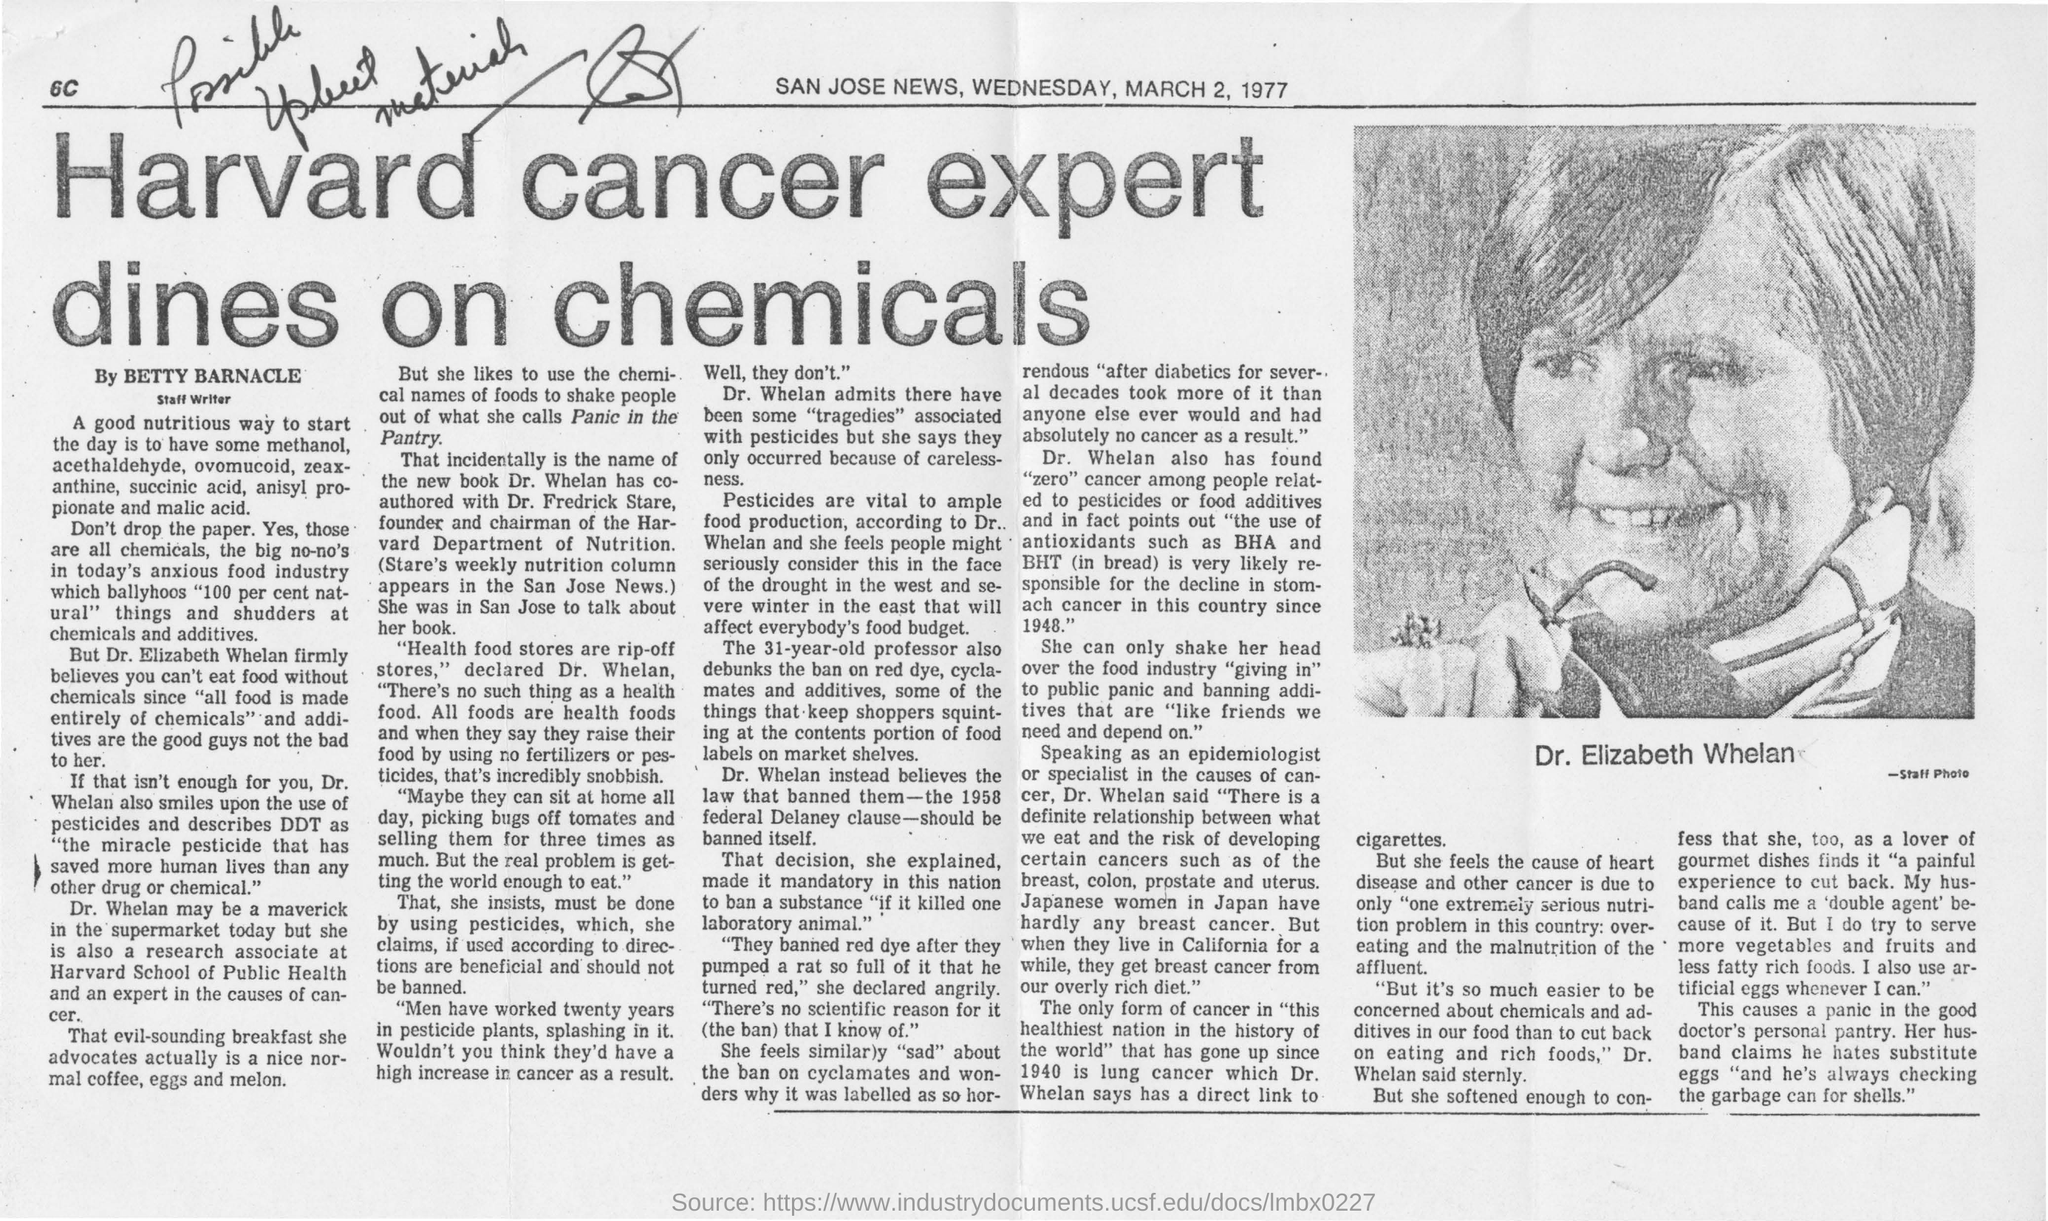Indicate a few pertinent items in this graphic. The newspaper features a picture of Dr. Elizabeth Whelan. The name of the newspaper is the SAN JOSE NEWS. According to Dr. Whelan, pesticides are essential for ensuring adequate food production. Harvard cancer expert is reportedly dining on chemicals. The date mentioned in the newspaper is March 2, 1977. 